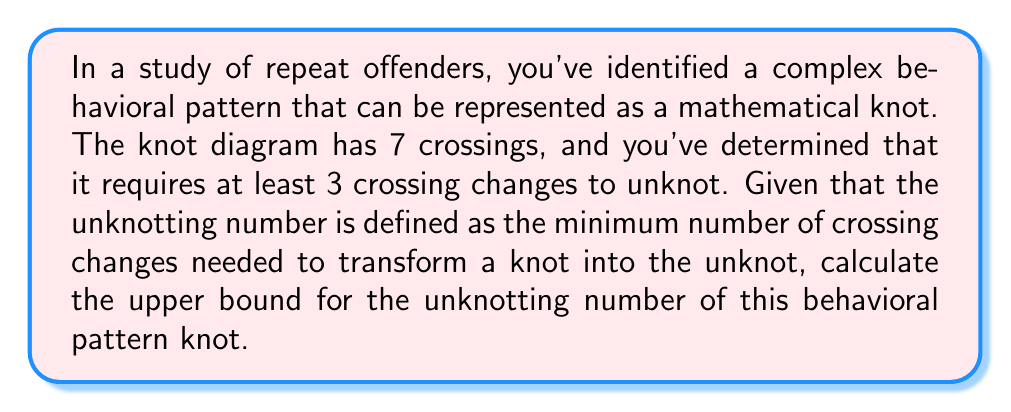Give your solution to this math problem. To solve this problem, we need to understand the concept of unknotting number and its properties:

1. The unknotting number $u(K)$ of a knot $K$ is the minimum number of crossing changes needed to transform the knot into the unknot.

2. An important property of the unknotting number is that it is always less than or equal to the number of crossings in any diagram of the knot. This gives us an upper bound.

3. In this case, we have a knot diagram with 7 crossings. Therefore, the initial upper bound for the unknotting number is 7.

4. However, we're given additional information that the knot requires at least 3 crossing changes to unknot. This means that the unknotting number is at least 3.

5. To find the upper bound, we use the minimum of:
   a) The total number of crossings (7)
   b) The given minimum number of crossing changes needed (3)

6. Therefore, the upper bound for the unknotting number is:

   $$u(K) \leq \min(7, 3) = 3$$

This means that the unknotting number is at most 3, which coincides with the given minimum number of crossing changes needed.
Answer: 3 